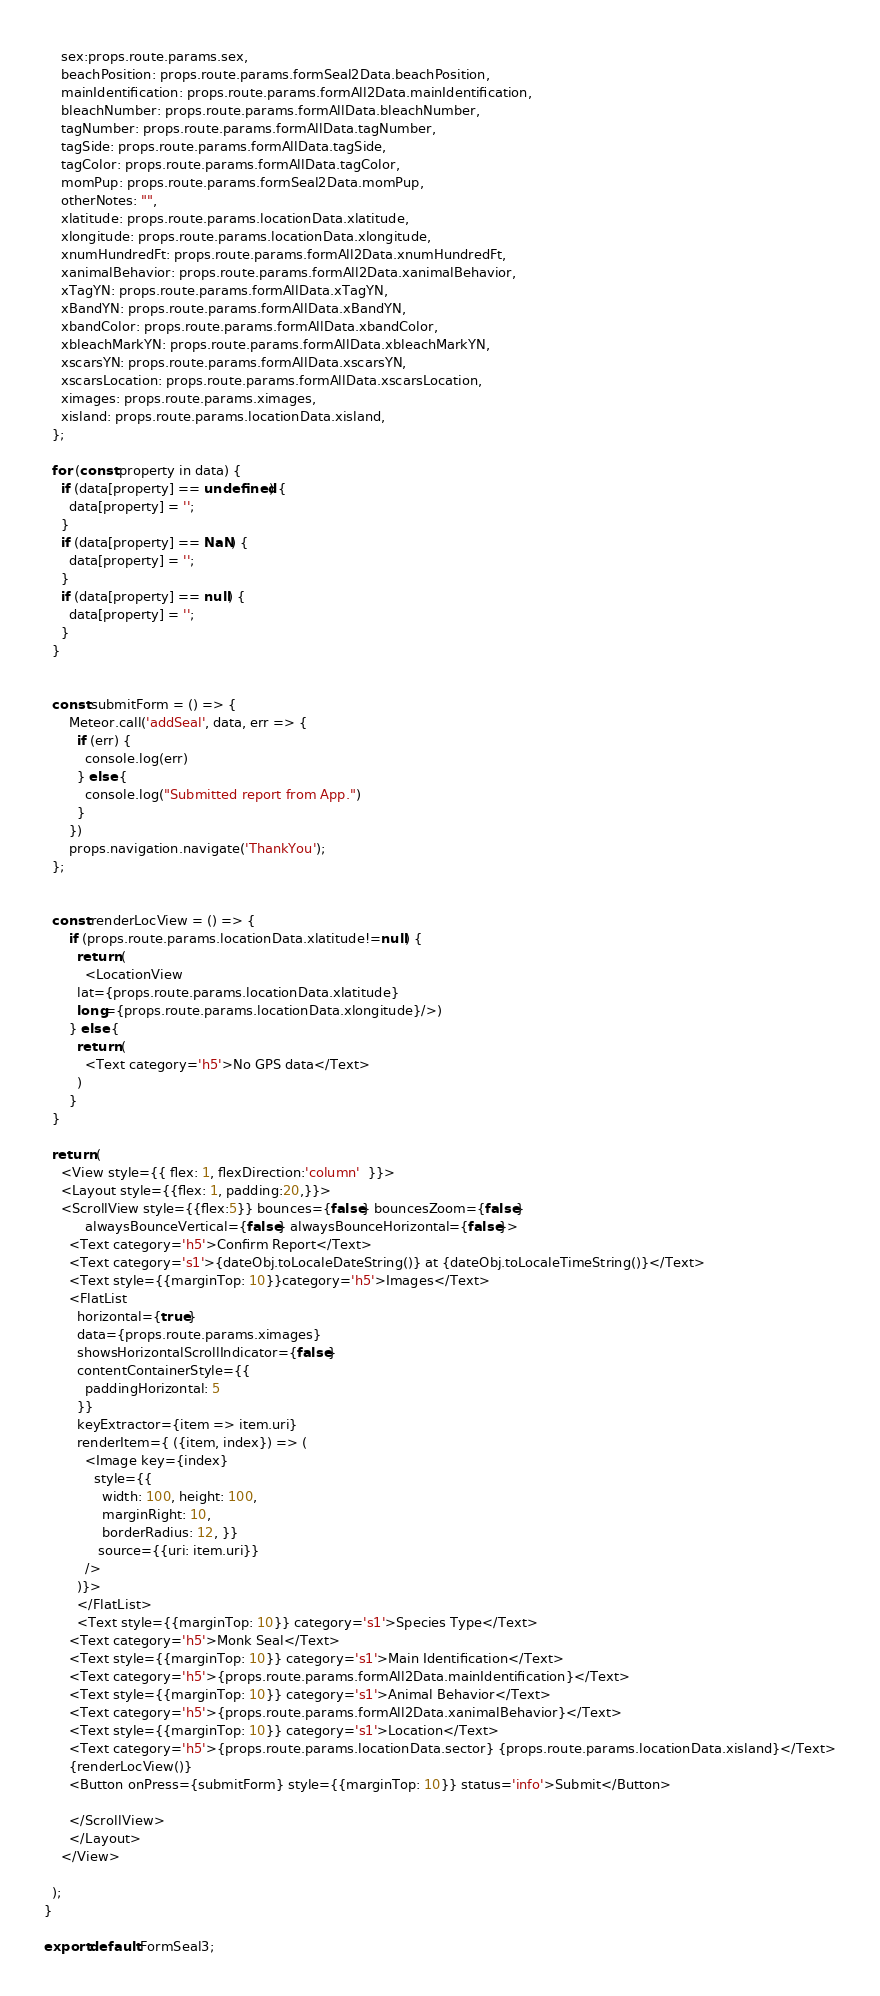<code> <loc_0><loc_0><loc_500><loc_500><_JavaScript_>    sex:props.route.params.sex,
    beachPosition: props.route.params.formSeal2Data.beachPosition,
    mainIdentification: props.route.params.formAll2Data.mainIdentification,
    bleachNumber: props.route.params.formAllData.bleachNumber,
    tagNumber: props.route.params.formAllData.tagNumber,
    tagSide: props.route.params.formAllData.tagSide,
    tagColor: props.route.params.formAllData.tagColor,
    momPup: props.route.params.formSeal2Data.momPup,
    otherNotes: "",
    xlatitude: props.route.params.locationData.xlatitude,
    xlongitude: props.route.params.locationData.xlongitude,
    xnumHundredFt: props.route.params.formAll2Data.xnumHundredFt,
    xanimalBehavior: props.route.params.formAll2Data.xanimalBehavior,
    xTagYN: props.route.params.formAllData.xTagYN,
    xBandYN: props.route.params.formAllData.xBandYN,
    xbandColor: props.route.params.formAllData.xbandColor,
    xbleachMarkYN: props.route.params.formAllData.xbleachMarkYN,
    xscarsYN: props.route.params.formAllData.xscarsYN,
    xscarsLocation: props.route.params.formAllData.xscarsLocation,
    ximages: props.route.params.ximages,
    xisland: props.route.params.locationData.xisland,
  };

  for (const property in data) {
    if (data[property] == undefined) {
      data[property] = '';
    }
    if (data[property] == NaN) {
      data[property] = '';
    }
    if (data[property] == null) {
      data[property] = '';
    }
  }
    

  const submitForm = () => {
      Meteor.call('addSeal', data, err => {
        if (err) {
          console.log(err)
        } else {
          console.log("Submitted report from App.")
        }
      }) 
      props.navigation.navigate('ThankYou');
  };


  const renderLocView = () => {
      if (props.route.params.locationData.xlatitude!=null) {
        return (
          <LocationView 
        lat={props.route.params.locationData.xlatitude} 
        long={props.route.params.locationData.xlongitude}/>)
      } else {
        return (
          <Text category='h5'>No GPS data</Text>
        )
      }
  }

  return (
    <View style={{ flex: 1, flexDirection:'column'  }}>
    <Layout style={{flex: 1, padding:20,}}>
    <ScrollView style={{flex:5}} bounces={false} bouncesZoom={false} 
          alwaysBounceVertical={false} alwaysBounceHorizontal={false}>
      <Text category='h5'>Confirm Report</Text>
      <Text category='s1'>{dateObj.toLocaleDateString()} at {dateObj.toLocaleTimeString()}</Text>
      <Text style={{marginTop: 10}}category='h5'>Images</Text>
      <FlatList
        horizontal={true}
        data={props.route.params.ximages}
        showsHorizontalScrollIndicator={false}
        contentContainerStyle={{
          paddingHorizontal: 5
        }}
        keyExtractor={item => item.uri}
        renderItem={ ({item, index}) => (
          <Image key={index}
            style={{
              width: 100, height: 100,
              marginRight: 10,
              borderRadius: 12, }}
             source={{uri: item.uri}}
          />
        )}>
        </FlatList>
        <Text style={{marginTop: 10}} category='s1'>Species Type</Text>
      <Text category='h5'>Monk Seal</Text>
      <Text style={{marginTop: 10}} category='s1'>Main Identification</Text>
      <Text category='h5'>{props.route.params.formAll2Data.mainIdentification}</Text>
      <Text style={{marginTop: 10}} category='s1'>Animal Behavior</Text>
      <Text category='h5'>{props.route.params.formAll2Data.xanimalBehavior}</Text>
      <Text style={{marginTop: 10}} category='s1'>Location</Text>
      <Text category='h5'>{props.route.params.locationData.sector} {props.route.params.locationData.xisland}</Text>
      {renderLocView()}
      <Button onPress={submitForm} style={{marginTop: 10}} status='info'>Submit</Button>

      </ScrollView>
      </Layout>
    </View>

  );
}

export default FormSeal3;</code> 